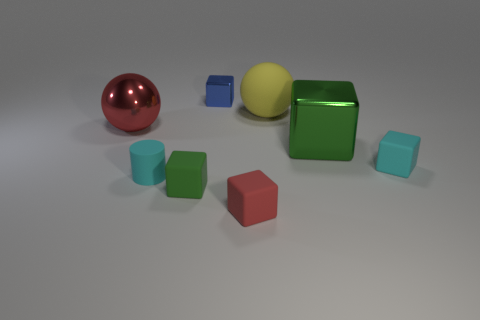Subtract all small green cubes. How many cubes are left? 4 Subtract 1 balls. How many balls are left? 1 Add 1 small cyan blocks. How many objects exist? 9 Subtract all red balls. How many balls are left? 1 Subtract all cylinders. How many objects are left? 7 Subtract all green balls. Subtract all yellow cubes. How many balls are left? 2 Subtract all yellow balls. How many red blocks are left? 1 Subtract all small blue cylinders. Subtract all big balls. How many objects are left? 6 Add 1 big yellow matte balls. How many big yellow matte balls are left? 2 Add 7 shiny spheres. How many shiny spheres exist? 8 